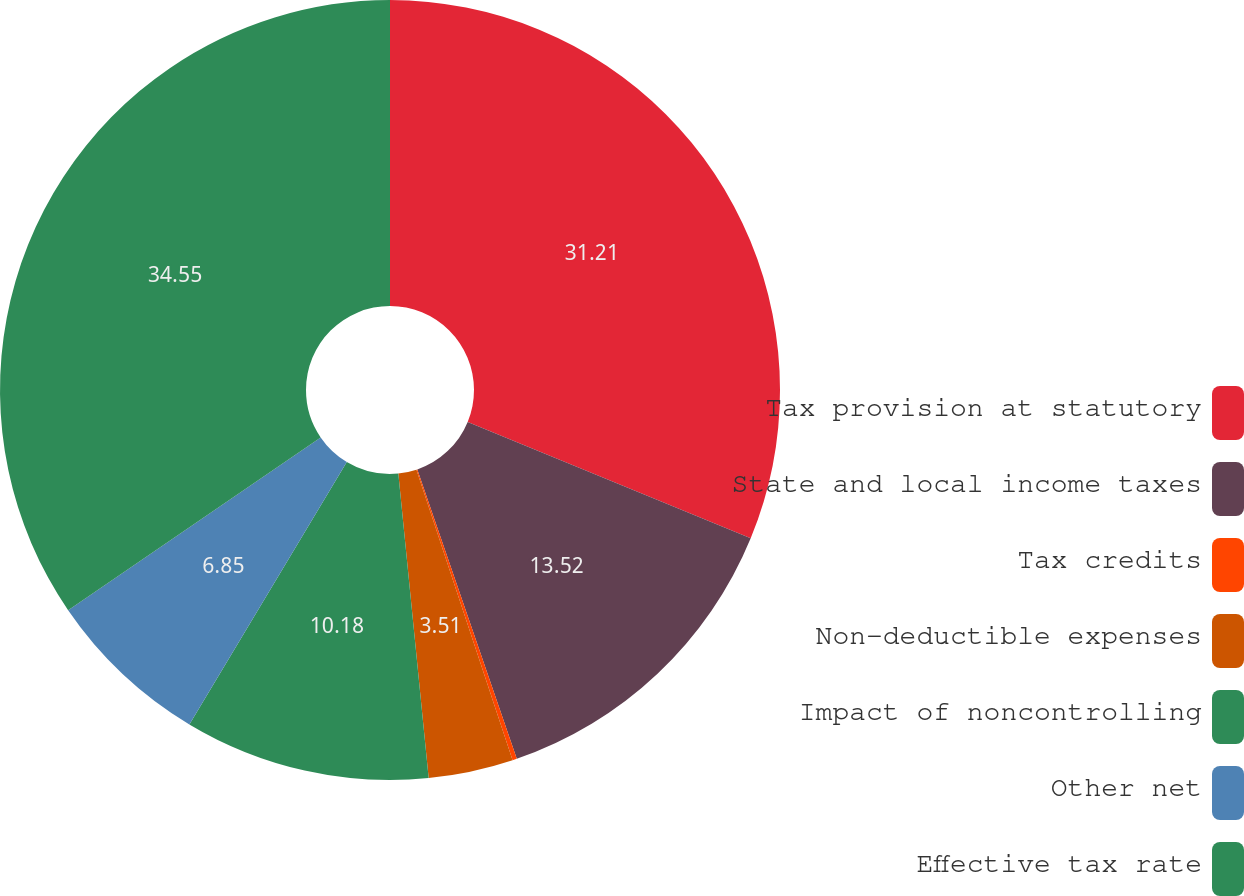<chart> <loc_0><loc_0><loc_500><loc_500><pie_chart><fcel>Tax provision at statutory<fcel>State and local income taxes<fcel>Tax credits<fcel>Non-deductible expenses<fcel>Impact of noncontrolling<fcel>Other net<fcel>Effective tax rate<nl><fcel>31.21%<fcel>13.52%<fcel>0.18%<fcel>3.51%<fcel>10.18%<fcel>6.85%<fcel>34.55%<nl></chart> 